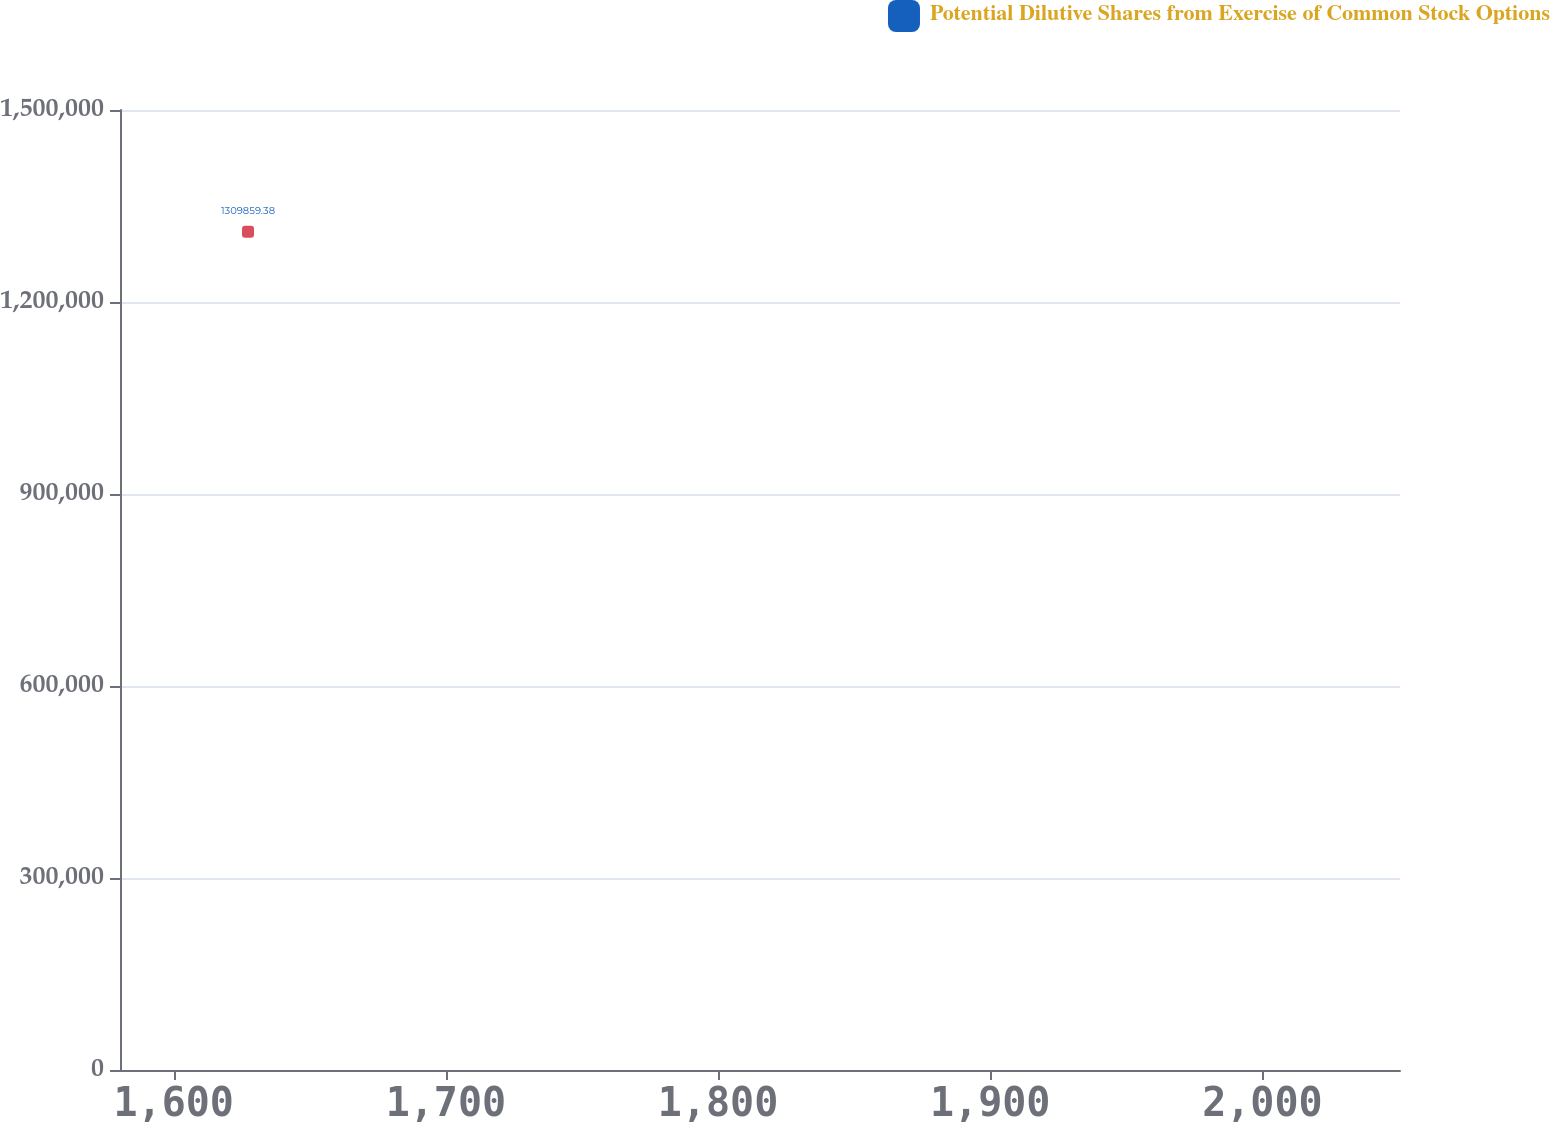Convert chart to OTSL. <chart><loc_0><loc_0><loc_500><loc_500><line_chart><ecel><fcel>Potential Dilutive Shares from Exercise of Common Stock Options<nl><fcel>1627.29<fcel>1.30986e+06<nl><fcel>2054.27<fcel>63612.9<nl><fcel>2097.61<fcel>244509<nl></chart> 